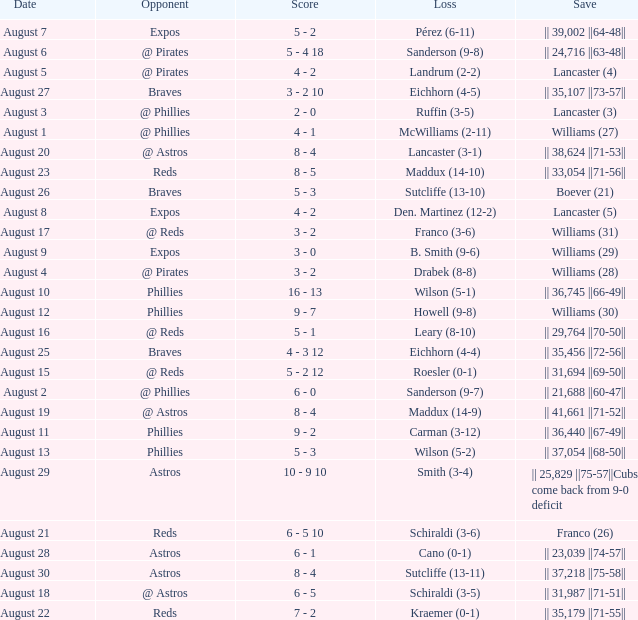Name the date for loss of ruffin (3-5) August 3. 